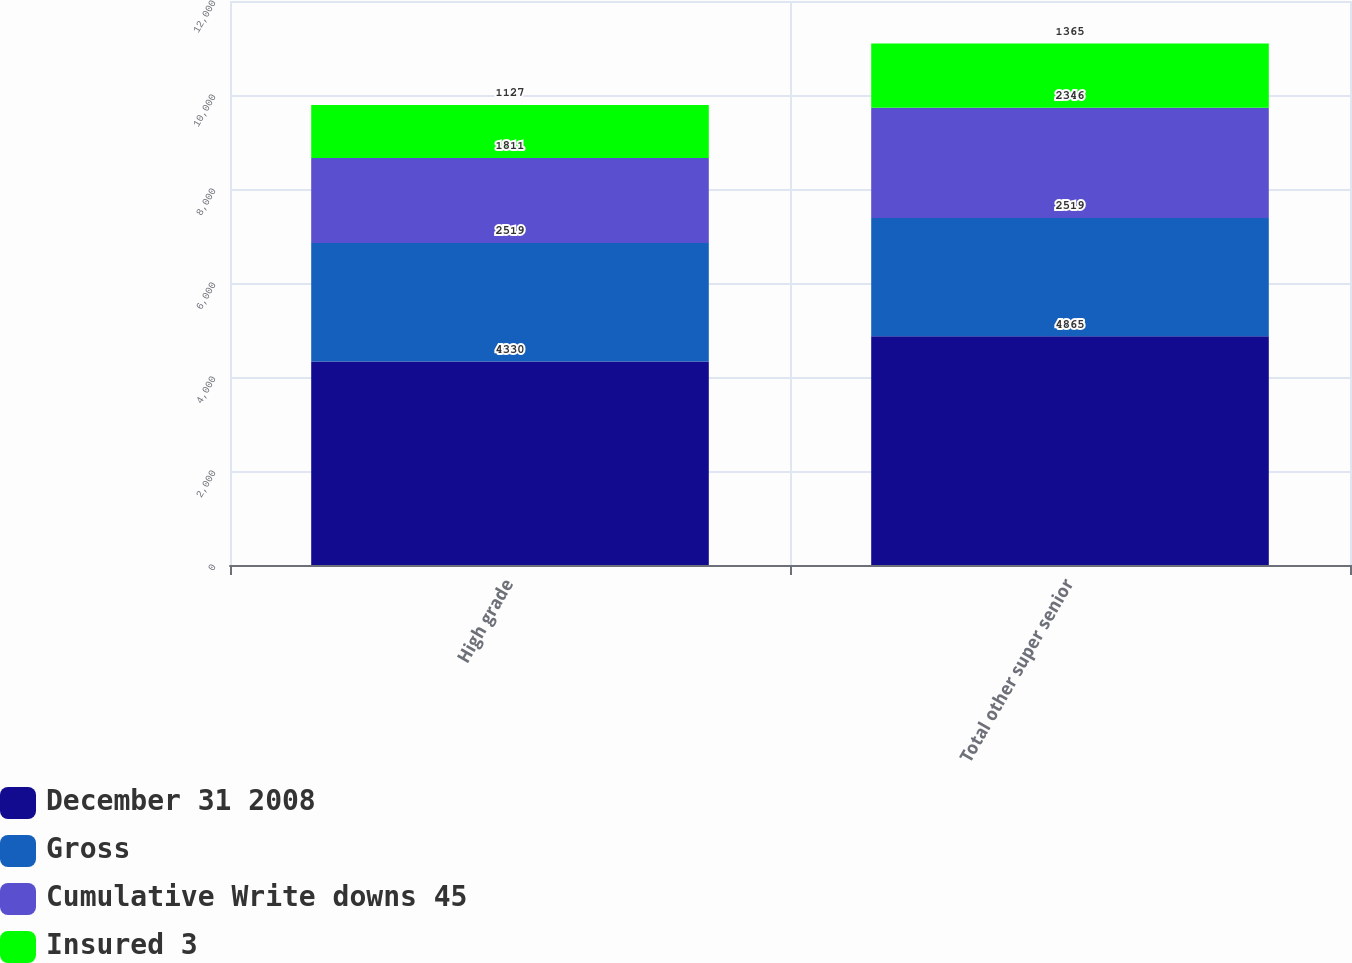Convert chart. <chart><loc_0><loc_0><loc_500><loc_500><stacked_bar_chart><ecel><fcel>High grade<fcel>Total other super senior<nl><fcel>December 31 2008<fcel>4330<fcel>4865<nl><fcel>Gross<fcel>2519<fcel>2519<nl><fcel>Cumulative Write downs 45<fcel>1811<fcel>2346<nl><fcel>Insured 3<fcel>1127<fcel>1365<nl></chart> 